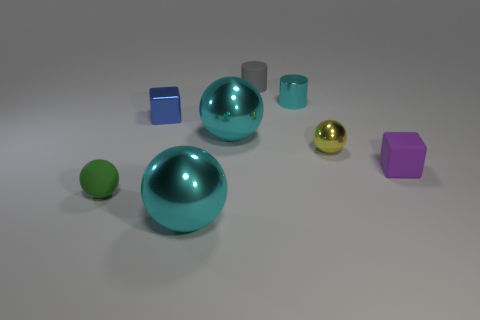Does the large cyan sphere that is in front of the tiny purple object have the same material as the small purple block?
Provide a succinct answer. No. The green matte object that is the same size as the cyan metal cylinder is what shape?
Offer a very short reply. Sphere. Are there any shiny things in front of the yellow metallic object?
Ensure brevity in your answer.  Yes. Does the small blue block in front of the small cyan metal thing have the same material as the cyan object in front of the tiny purple rubber object?
Offer a very short reply. Yes. How many cylinders have the same size as the yellow metallic ball?
Offer a very short reply. 2. What is the material of the sphere right of the small cyan metallic object?
Ensure brevity in your answer.  Metal. How many small blue shiny objects are the same shape as the small purple object?
Your response must be concise. 1. There is a small cyan thing that is the same material as the yellow thing; what shape is it?
Your answer should be compact. Cylinder. What is the shape of the tiny shiny thing that is left of the large ball to the left of the shiny ball that is behind the tiny metallic sphere?
Provide a succinct answer. Cube. Is the number of small blue metallic blocks greater than the number of small red cylinders?
Offer a very short reply. Yes. 